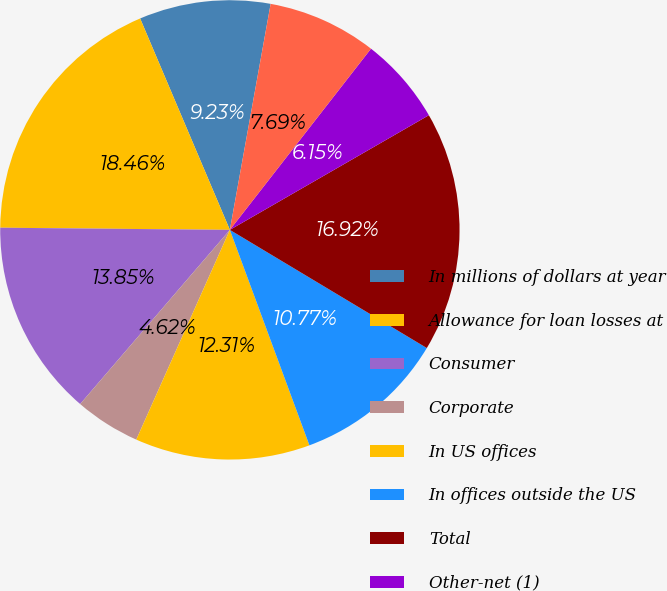<chart> <loc_0><loc_0><loc_500><loc_500><pie_chart><fcel>In millions of dollars at year<fcel>Allowance for loan losses at<fcel>Consumer<fcel>Corporate<fcel>In US offices<fcel>In offices outside the US<fcel>Total<fcel>Other-net (1)<fcel>Allowance for unfunded lending<nl><fcel>9.23%<fcel>18.46%<fcel>13.85%<fcel>4.62%<fcel>12.31%<fcel>10.77%<fcel>16.92%<fcel>6.15%<fcel>7.69%<nl></chart> 